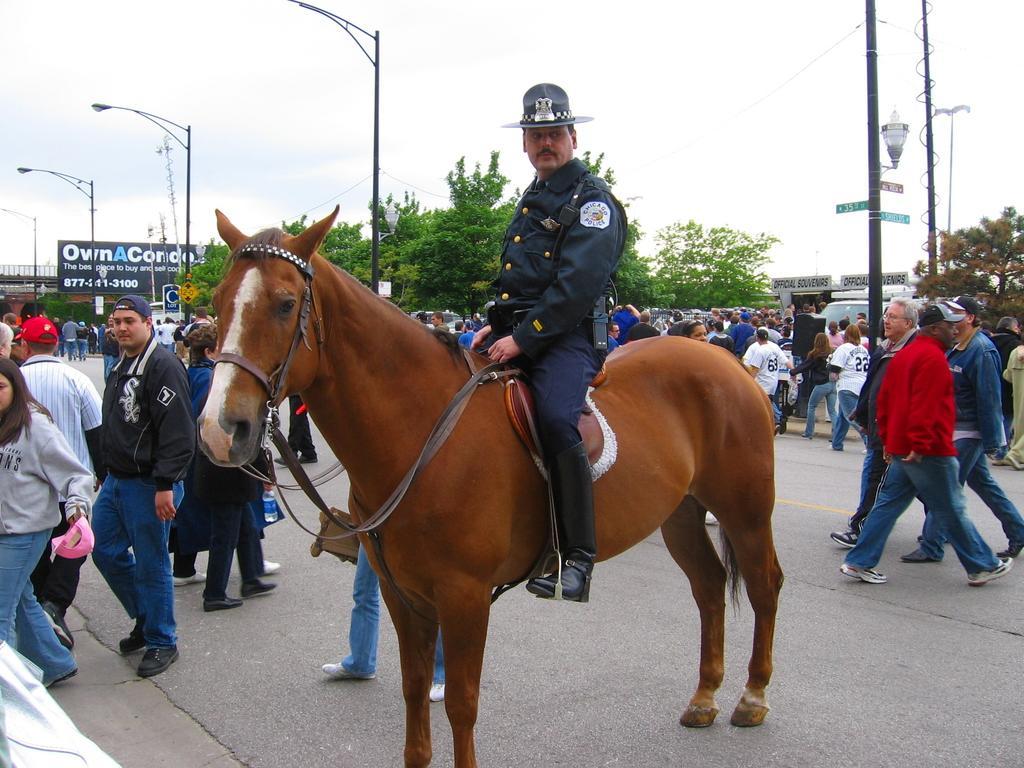Describe this image in one or two sentences. In this image there are group of persons who are walking on the ground at the middle of the image there is a person sitting on the horse and at the background of the image there are trees and sky. 